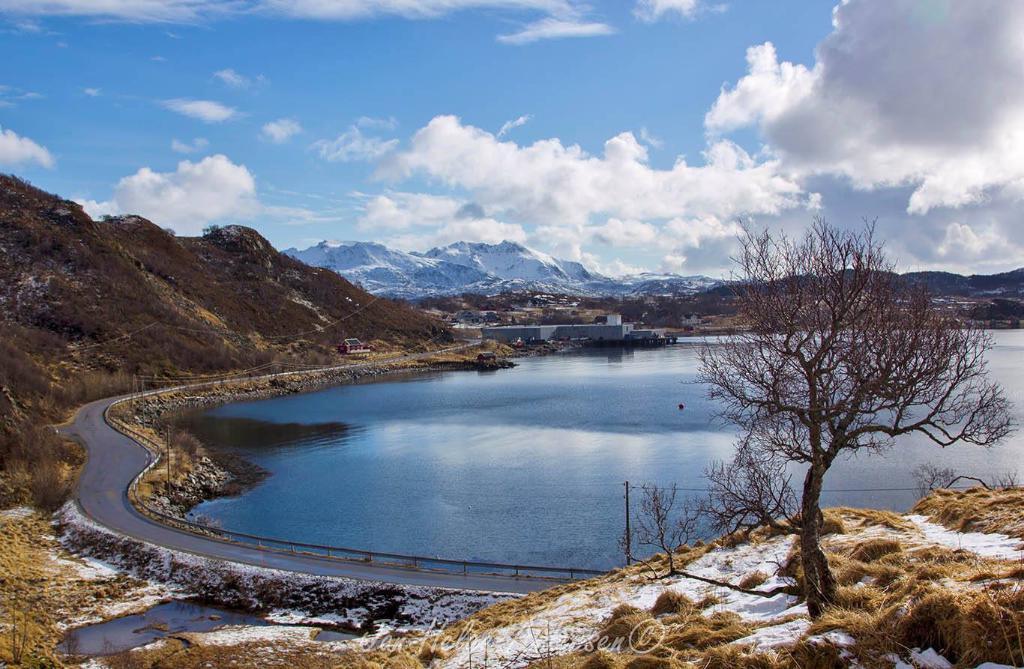How would you summarize this image in a sentence or two? In this image we can see sky with clouds, hills, mountains, buildings, road, fence, electric poles, electric cables, grass, trees and river. 